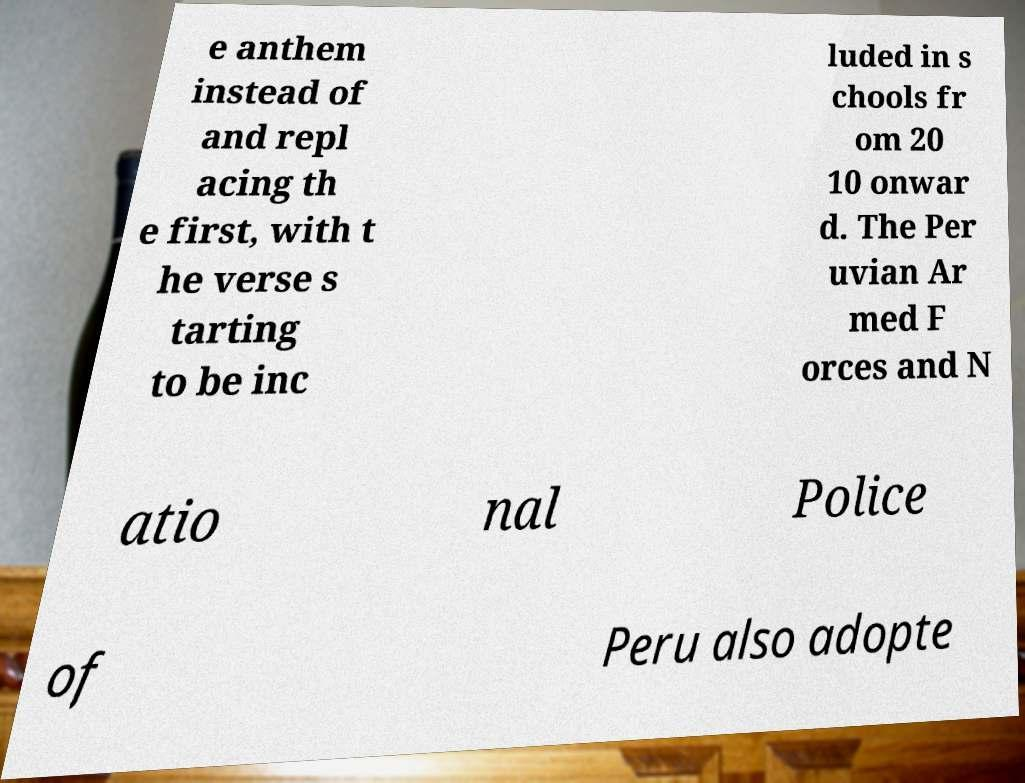Could you assist in decoding the text presented in this image and type it out clearly? e anthem instead of and repl acing th e first, with t he verse s tarting to be inc luded in s chools fr om 20 10 onwar d. The Per uvian Ar med F orces and N atio nal Police of Peru also adopte 